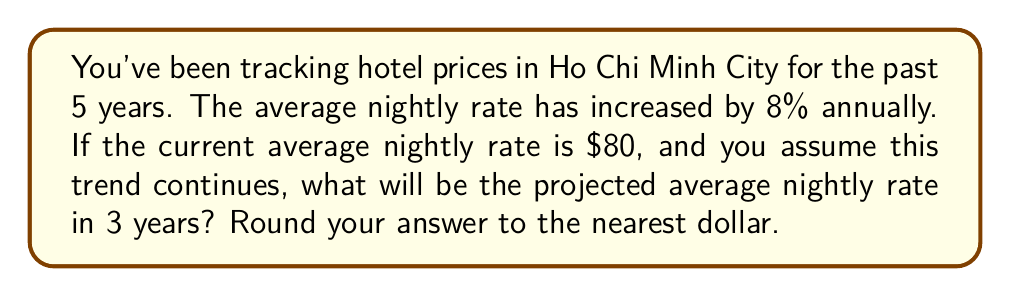Can you answer this question? Let's approach this step-by-step:

1) First, we need to understand the growth rate. An 8% annual increase means the price is multiplied by 1.08 each year.

2) We want to project 3 years into the future, so we'll apply this growth factor three times.

3) Let's call our initial price $P_0$ and the price after 3 years $P_3$. We can express this mathematically as:

   $$P_3 = P_0 \times (1.08)^3$$

4) We know that $P_0 = $80, so let's substitute this:

   $$P_3 = 80 \times (1.08)^3$$

5) Now, let's calculate:
   
   $$P_3 = 80 \times 1.259712 = 100.77696$$

6) Rounding to the nearest dollar:

   $$P_3 \approx $101$$
Answer: $101 